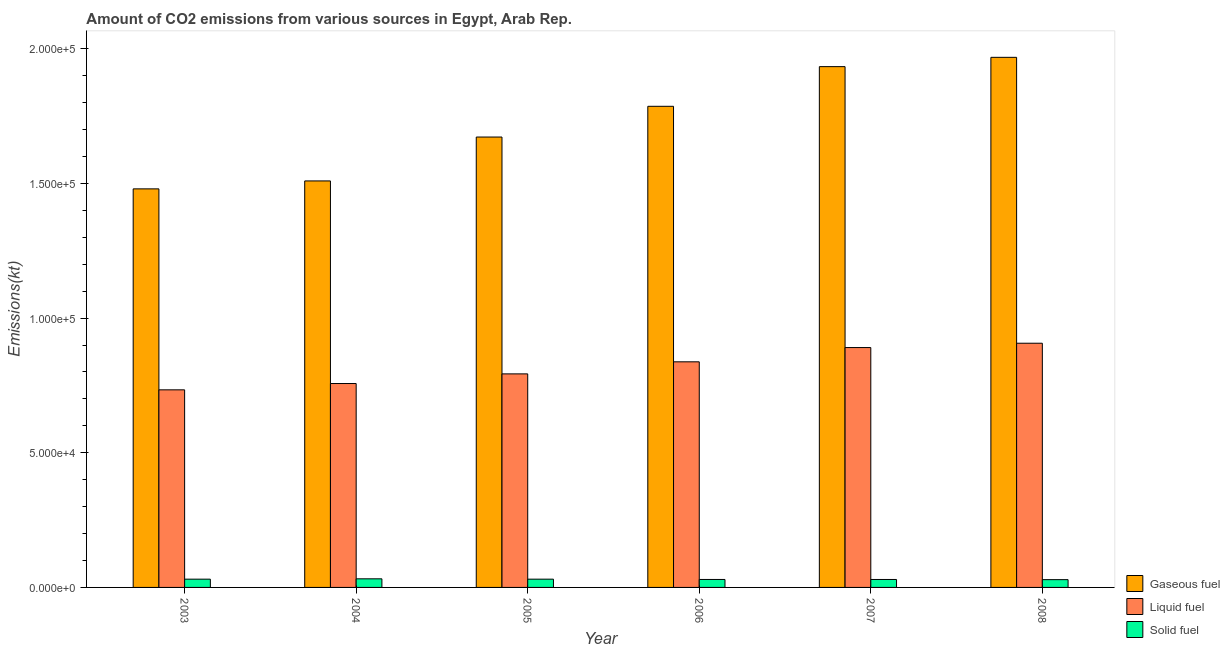How many different coloured bars are there?
Your response must be concise. 3. How many groups of bars are there?
Keep it short and to the point. 6. How many bars are there on the 2nd tick from the left?
Your answer should be compact. 3. How many bars are there on the 5th tick from the right?
Give a very brief answer. 3. What is the amount of co2 emissions from gaseous fuel in 2005?
Keep it short and to the point. 1.67e+05. Across all years, what is the maximum amount of co2 emissions from gaseous fuel?
Ensure brevity in your answer.  1.97e+05. Across all years, what is the minimum amount of co2 emissions from gaseous fuel?
Give a very brief answer. 1.48e+05. In which year was the amount of co2 emissions from solid fuel maximum?
Keep it short and to the point. 2004. In which year was the amount of co2 emissions from gaseous fuel minimum?
Offer a very short reply. 2003. What is the total amount of co2 emissions from liquid fuel in the graph?
Provide a succinct answer. 4.92e+05. What is the difference between the amount of co2 emissions from gaseous fuel in 2003 and that in 2004?
Keep it short and to the point. -2948.27. What is the difference between the amount of co2 emissions from liquid fuel in 2007 and the amount of co2 emissions from solid fuel in 2006?
Your answer should be very brief. 5291.48. What is the average amount of co2 emissions from solid fuel per year?
Offer a terse response. 3021. In the year 2006, what is the difference between the amount of co2 emissions from gaseous fuel and amount of co2 emissions from liquid fuel?
Your answer should be compact. 0. What is the ratio of the amount of co2 emissions from gaseous fuel in 2003 to that in 2004?
Your response must be concise. 0.98. Is the amount of co2 emissions from solid fuel in 2004 less than that in 2008?
Your answer should be very brief. No. What is the difference between the highest and the second highest amount of co2 emissions from gaseous fuel?
Your answer should be compact. 3454.31. What is the difference between the highest and the lowest amount of co2 emissions from liquid fuel?
Offer a very short reply. 1.73e+04. In how many years, is the amount of co2 emissions from liquid fuel greater than the average amount of co2 emissions from liquid fuel taken over all years?
Keep it short and to the point. 3. What does the 3rd bar from the left in 2006 represents?
Your response must be concise. Solid fuel. What does the 2nd bar from the right in 2005 represents?
Offer a terse response. Liquid fuel. Is it the case that in every year, the sum of the amount of co2 emissions from gaseous fuel and amount of co2 emissions from liquid fuel is greater than the amount of co2 emissions from solid fuel?
Your response must be concise. Yes. How many years are there in the graph?
Your answer should be compact. 6. Are the values on the major ticks of Y-axis written in scientific E-notation?
Your answer should be very brief. Yes. How many legend labels are there?
Provide a short and direct response. 3. What is the title of the graph?
Provide a succinct answer. Amount of CO2 emissions from various sources in Egypt, Arab Rep. What is the label or title of the X-axis?
Your answer should be very brief. Year. What is the label or title of the Y-axis?
Ensure brevity in your answer.  Emissions(kt). What is the Emissions(kt) of Gaseous fuel in 2003?
Give a very brief answer. 1.48e+05. What is the Emissions(kt) of Liquid fuel in 2003?
Offer a very short reply. 7.34e+04. What is the Emissions(kt) in Solid fuel in 2003?
Your answer should be very brief. 3065.61. What is the Emissions(kt) of Gaseous fuel in 2004?
Give a very brief answer. 1.51e+05. What is the Emissions(kt) in Liquid fuel in 2004?
Ensure brevity in your answer.  7.57e+04. What is the Emissions(kt) of Solid fuel in 2004?
Offer a very short reply. 3193.96. What is the Emissions(kt) in Gaseous fuel in 2005?
Offer a very short reply. 1.67e+05. What is the Emissions(kt) in Liquid fuel in 2005?
Offer a very short reply. 7.93e+04. What is the Emissions(kt) of Solid fuel in 2005?
Make the answer very short. 3069.28. What is the Emissions(kt) of Gaseous fuel in 2006?
Your response must be concise. 1.79e+05. What is the Emissions(kt) of Liquid fuel in 2006?
Make the answer very short. 8.38e+04. What is the Emissions(kt) in Solid fuel in 2006?
Your answer should be compact. 2959.27. What is the Emissions(kt) of Gaseous fuel in 2007?
Your answer should be compact. 1.93e+05. What is the Emissions(kt) of Liquid fuel in 2007?
Make the answer very short. 8.90e+04. What is the Emissions(kt) in Solid fuel in 2007?
Your answer should be compact. 2951.93. What is the Emissions(kt) in Gaseous fuel in 2008?
Provide a short and direct response. 1.97e+05. What is the Emissions(kt) in Liquid fuel in 2008?
Your answer should be compact. 9.07e+04. What is the Emissions(kt) of Solid fuel in 2008?
Ensure brevity in your answer.  2885.93. Across all years, what is the maximum Emissions(kt) of Gaseous fuel?
Offer a very short reply. 1.97e+05. Across all years, what is the maximum Emissions(kt) of Liquid fuel?
Provide a short and direct response. 9.07e+04. Across all years, what is the maximum Emissions(kt) in Solid fuel?
Provide a succinct answer. 3193.96. Across all years, what is the minimum Emissions(kt) in Gaseous fuel?
Offer a very short reply. 1.48e+05. Across all years, what is the minimum Emissions(kt) of Liquid fuel?
Your response must be concise. 7.34e+04. Across all years, what is the minimum Emissions(kt) of Solid fuel?
Ensure brevity in your answer.  2885.93. What is the total Emissions(kt) in Gaseous fuel in the graph?
Make the answer very short. 1.03e+06. What is the total Emissions(kt) in Liquid fuel in the graph?
Offer a very short reply. 4.92e+05. What is the total Emissions(kt) of Solid fuel in the graph?
Your response must be concise. 1.81e+04. What is the difference between the Emissions(kt) of Gaseous fuel in 2003 and that in 2004?
Offer a very short reply. -2948.27. What is the difference between the Emissions(kt) in Liquid fuel in 2003 and that in 2004?
Provide a short and direct response. -2343.21. What is the difference between the Emissions(kt) in Solid fuel in 2003 and that in 2004?
Provide a short and direct response. -128.34. What is the difference between the Emissions(kt) of Gaseous fuel in 2003 and that in 2005?
Your response must be concise. -1.92e+04. What is the difference between the Emissions(kt) in Liquid fuel in 2003 and that in 2005?
Ensure brevity in your answer.  -5922.2. What is the difference between the Emissions(kt) in Solid fuel in 2003 and that in 2005?
Offer a terse response. -3.67. What is the difference between the Emissions(kt) of Gaseous fuel in 2003 and that in 2006?
Provide a succinct answer. -3.07e+04. What is the difference between the Emissions(kt) in Liquid fuel in 2003 and that in 2006?
Your answer should be very brief. -1.04e+04. What is the difference between the Emissions(kt) of Solid fuel in 2003 and that in 2006?
Your answer should be compact. 106.34. What is the difference between the Emissions(kt) of Gaseous fuel in 2003 and that in 2007?
Offer a very short reply. -4.54e+04. What is the difference between the Emissions(kt) in Liquid fuel in 2003 and that in 2007?
Your answer should be compact. -1.57e+04. What is the difference between the Emissions(kt) in Solid fuel in 2003 and that in 2007?
Provide a short and direct response. 113.68. What is the difference between the Emissions(kt) in Gaseous fuel in 2003 and that in 2008?
Your answer should be very brief. -4.88e+04. What is the difference between the Emissions(kt) of Liquid fuel in 2003 and that in 2008?
Make the answer very short. -1.73e+04. What is the difference between the Emissions(kt) of Solid fuel in 2003 and that in 2008?
Offer a very short reply. 179.68. What is the difference between the Emissions(kt) in Gaseous fuel in 2004 and that in 2005?
Provide a succinct answer. -1.63e+04. What is the difference between the Emissions(kt) of Liquid fuel in 2004 and that in 2005?
Your answer should be very brief. -3578.99. What is the difference between the Emissions(kt) in Solid fuel in 2004 and that in 2005?
Your answer should be compact. 124.68. What is the difference between the Emissions(kt) in Gaseous fuel in 2004 and that in 2006?
Ensure brevity in your answer.  -2.77e+04. What is the difference between the Emissions(kt) of Liquid fuel in 2004 and that in 2006?
Your response must be concise. -8060.07. What is the difference between the Emissions(kt) of Solid fuel in 2004 and that in 2006?
Offer a very short reply. 234.69. What is the difference between the Emissions(kt) in Gaseous fuel in 2004 and that in 2007?
Ensure brevity in your answer.  -4.24e+04. What is the difference between the Emissions(kt) in Liquid fuel in 2004 and that in 2007?
Offer a terse response. -1.34e+04. What is the difference between the Emissions(kt) in Solid fuel in 2004 and that in 2007?
Your answer should be very brief. 242.02. What is the difference between the Emissions(kt) in Gaseous fuel in 2004 and that in 2008?
Make the answer very short. -4.59e+04. What is the difference between the Emissions(kt) of Liquid fuel in 2004 and that in 2008?
Give a very brief answer. -1.50e+04. What is the difference between the Emissions(kt) in Solid fuel in 2004 and that in 2008?
Offer a terse response. 308.03. What is the difference between the Emissions(kt) in Gaseous fuel in 2005 and that in 2006?
Provide a succinct answer. -1.14e+04. What is the difference between the Emissions(kt) in Liquid fuel in 2005 and that in 2006?
Your answer should be very brief. -4481.07. What is the difference between the Emissions(kt) in Solid fuel in 2005 and that in 2006?
Provide a succinct answer. 110.01. What is the difference between the Emissions(kt) of Gaseous fuel in 2005 and that in 2007?
Keep it short and to the point. -2.61e+04. What is the difference between the Emissions(kt) in Liquid fuel in 2005 and that in 2007?
Offer a terse response. -9772.56. What is the difference between the Emissions(kt) in Solid fuel in 2005 and that in 2007?
Ensure brevity in your answer.  117.34. What is the difference between the Emissions(kt) of Gaseous fuel in 2005 and that in 2008?
Make the answer very short. -2.96e+04. What is the difference between the Emissions(kt) in Liquid fuel in 2005 and that in 2008?
Keep it short and to the point. -1.14e+04. What is the difference between the Emissions(kt) of Solid fuel in 2005 and that in 2008?
Make the answer very short. 183.35. What is the difference between the Emissions(kt) in Gaseous fuel in 2006 and that in 2007?
Provide a succinct answer. -1.47e+04. What is the difference between the Emissions(kt) of Liquid fuel in 2006 and that in 2007?
Offer a terse response. -5291.48. What is the difference between the Emissions(kt) in Solid fuel in 2006 and that in 2007?
Your answer should be compact. 7.33. What is the difference between the Emissions(kt) in Gaseous fuel in 2006 and that in 2008?
Your answer should be very brief. -1.82e+04. What is the difference between the Emissions(kt) of Liquid fuel in 2006 and that in 2008?
Your answer should be very brief. -6901.29. What is the difference between the Emissions(kt) of Solid fuel in 2006 and that in 2008?
Your response must be concise. 73.34. What is the difference between the Emissions(kt) in Gaseous fuel in 2007 and that in 2008?
Your response must be concise. -3454.31. What is the difference between the Emissions(kt) in Liquid fuel in 2007 and that in 2008?
Provide a succinct answer. -1609.81. What is the difference between the Emissions(kt) of Solid fuel in 2007 and that in 2008?
Make the answer very short. 66.01. What is the difference between the Emissions(kt) in Gaseous fuel in 2003 and the Emissions(kt) in Liquid fuel in 2004?
Provide a succinct answer. 7.23e+04. What is the difference between the Emissions(kt) of Gaseous fuel in 2003 and the Emissions(kt) of Solid fuel in 2004?
Your answer should be very brief. 1.45e+05. What is the difference between the Emissions(kt) in Liquid fuel in 2003 and the Emissions(kt) in Solid fuel in 2004?
Keep it short and to the point. 7.02e+04. What is the difference between the Emissions(kt) of Gaseous fuel in 2003 and the Emissions(kt) of Liquid fuel in 2005?
Your answer should be compact. 6.87e+04. What is the difference between the Emissions(kt) of Gaseous fuel in 2003 and the Emissions(kt) of Solid fuel in 2005?
Your answer should be compact. 1.45e+05. What is the difference between the Emissions(kt) of Liquid fuel in 2003 and the Emissions(kt) of Solid fuel in 2005?
Make the answer very short. 7.03e+04. What is the difference between the Emissions(kt) of Gaseous fuel in 2003 and the Emissions(kt) of Liquid fuel in 2006?
Make the answer very short. 6.42e+04. What is the difference between the Emissions(kt) of Gaseous fuel in 2003 and the Emissions(kt) of Solid fuel in 2006?
Your response must be concise. 1.45e+05. What is the difference between the Emissions(kt) of Liquid fuel in 2003 and the Emissions(kt) of Solid fuel in 2006?
Ensure brevity in your answer.  7.04e+04. What is the difference between the Emissions(kt) of Gaseous fuel in 2003 and the Emissions(kt) of Liquid fuel in 2007?
Your answer should be very brief. 5.89e+04. What is the difference between the Emissions(kt) of Gaseous fuel in 2003 and the Emissions(kt) of Solid fuel in 2007?
Provide a succinct answer. 1.45e+05. What is the difference between the Emissions(kt) of Liquid fuel in 2003 and the Emissions(kt) of Solid fuel in 2007?
Provide a short and direct response. 7.04e+04. What is the difference between the Emissions(kt) of Gaseous fuel in 2003 and the Emissions(kt) of Liquid fuel in 2008?
Provide a succinct answer. 5.73e+04. What is the difference between the Emissions(kt) of Gaseous fuel in 2003 and the Emissions(kt) of Solid fuel in 2008?
Ensure brevity in your answer.  1.45e+05. What is the difference between the Emissions(kt) in Liquid fuel in 2003 and the Emissions(kt) in Solid fuel in 2008?
Provide a succinct answer. 7.05e+04. What is the difference between the Emissions(kt) of Gaseous fuel in 2004 and the Emissions(kt) of Liquid fuel in 2005?
Offer a terse response. 7.16e+04. What is the difference between the Emissions(kt) in Gaseous fuel in 2004 and the Emissions(kt) in Solid fuel in 2005?
Offer a terse response. 1.48e+05. What is the difference between the Emissions(kt) of Liquid fuel in 2004 and the Emissions(kt) of Solid fuel in 2005?
Offer a very short reply. 7.26e+04. What is the difference between the Emissions(kt) in Gaseous fuel in 2004 and the Emissions(kt) in Liquid fuel in 2006?
Offer a terse response. 6.72e+04. What is the difference between the Emissions(kt) in Gaseous fuel in 2004 and the Emissions(kt) in Solid fuel in 2006?
Offer a terse response. 1.48e+05. What is the difference between the Emissions(kt) in Liquid fuel in 2004 and the Emissions(kt) in Solid fuel in 2006?
Offer a very short reply. 7.27e+04. What is the difference between the Emissions(kt) of Gaseous fuel in 2004 and the Emissions(kt) of Liquid fuel in 2007?
Offer a very short reply. 6.19e+04. What is the difference between the Emissions(kt) of Gaseous fuel in 2004 and the Emissions(kt) of Solid fuel in 2007?
Your answer should be very brief. 1.48e+05. What is the difference between the Emissions(kt) in Liquid fuel in 2004 and the Emissions(kt) in Solid fuel in 2007?
Ensure brevity in your answer.  7.27e+04. What is the difference between the Emissions(kt) of Gaseous fuel in 2004 and the Emissions(kt) of Liquid fuel in 2008?
Your answer should be compact. 6.03e+04. What is the difference between the Emissions(kt) in Gaseous fuel in 2004 and the Emissions(kt) in Solid fuel in 2008?
Offer a terse response. 1.48e+05. What is the difference between the Emissions(kt) of Liquid fuel in 2004 and the Emissions(kt) of Solid fuel in 2008?
Give a very brief answer. 7.28e+04. What is the difference between the Emissions(kt) of Gaseous fuel in 2005 and the Emissions(kt) of Liquid fuel in 2006?
Your answer should be compact. 8.34e+04. What is the difference between the Emissions(kt) of Gaseous fuel in 2005 and the Emissions(kt) of Solid fuel in 2006?
Your response must be concise. 1.64e+05. What is the difference between the Emissions(kt) of Liquid fuel in 2005 and the Emissions(kt) of Solid fuel in 2006?
Provide a short and direct response. 7.63e+04. What is the difference between the Emissions(kt) in Gaseous fuel in 2005 and the Emissions(kt) in Liquid fuel in 2007?
Offer a terse response. 7.82e+04. What is the difference between the Emissions(kt) of Gaseous fuel in 2005 and the Emissions(kt) of Solid fuel in 2007?
Keep it short and to the point. 1.64e+05. What is the difference between the Emissions(kt) in Liquid fuel in 2005 and the Emissions(kt) in Solid fuel in 2007?
Give a very brief answer. 7.63e+04. What is the difference between the Emissions(kt) in Gaseous fuel in 2005 and the Emissions(kt) in Liquid fuel in 2008?
Offer a very short reply. 7.65e+04. What is the difference between the Emissions(kt) in Gaseous fuel in 2005 and the Emissions(kt) in Solid fuel in 2008?
Keep it short and to the point. 1.64e+05. What is the difference between the Emissions(kt) of Liquid fuel in 2005 and the Emissions(kt) of Solid fuel in 2008?
Ensure brevity in your answer.  7.64e+04. What is the difference between the Emissions(kt) in Gaseous fuel in 2006 and the Emissions(kt) in Liquid fuel in 2007?
Keep it short and to the point. 8.96e+04. What is the difference between the Emissions(kt) in Gaseous fuel in 2006 and the Emissions(kt) in Solid fuel in 2007?
Your answer should be compact. 1.76e+05. What is the difference between the Emissions(kt) of Liquid fuel in 2006 and the Emissions(kt) of Solid fuel in 2007?
Offer a very short reply. 8.08e+04. What is the difference between the Emissions(kt) of Gaseous fuel in 2006 and the Emissions(kt) of Liquid fuel in 2008?
Make the answer very short. 8.80e+04. What is the difference between the Emissions(kt) of Gaseous fuel in 2006 and the Emissions(kt) of Solid fuel in 2008?
Offer a terse response. 1.76e+05. What is the difference between the Emissions(kt) of Liquid fuel in 2006 and the Emissions(kt) of Solid fuel in 2008?
Your answer should be compact. 8.09e+04. What is the difference between the Emissions(kt) in Gaseous fuel in 2007 and the Emissions(kt) in Liquid fuel in 2008?
Your answer should be compact. 1.03e+05. What is the difference between the Emissions(kt) of Gaseous fuel in 2007 and the Emissions(kt) of Solid fuel in 2008?
Your response must be concise. 1.90e+05. What is the difference between the Emissions(kt) of Liquid fuel in 2007 and the Emissions(kt) of Solid fuel in 2008?
Ensure brevity in your answer.  8.62e+04. What is the average Emissions(kt) of Gaseous fuel per year?
Ensure brevity in your answer.  1.72e+05. What is the average Emissions(kt) in Liquid fuel per year?
Your answer should be very brief. 8.20e+04. What is the average Emissions(kt) of Solid fuel per year?
Provide a succinct answer. 3021. In the year 2003, what is the difference between the Emissions(kt) in Gaseous fuel and Emissions(kt) in Liquid fuel?
Your answer should be compact. 7.46e+04. In the year 2003, what is the difference between the Emissions(kt) of Gaseous fuel and Emissions(kt) of Solid fuel?
Make the answer very short. 1.45e+05. In the year 2003, what is the difference between the Emissions(kt) in Liquid fuel and Emissions(kt) in Solid fuel?
Give a very brief answer. 7.03e+04. In the year 2004, what is the difference between the Emissions(kt) of Gaseous fuel and Emissions(kt) of Liquid fuel?
Your answer should be compact. 7.52e+04. In the year 2004, what is the difference between the Emissions(kt) of Gaseous fuel and Emissions(kt) of Solid fuel?
Offer a terse response. 1.48e+05. In the year 2004, what is the difference between the Emissions(kt) in Liquid fuel and Emissions(kt) in Solid fuel?
Ensure brevity in your answer.  7.25e+04. In the year 2005, what is the difference between the Emissions(kt) in Gaseous fuel and Emissions(kt) in Liquid fuel?
Provide a short and direct response. 8.79e+04. In the year 2005, what is the difference between the Emissions(kt) of Gaseous fuel and Emissions(kt) of Solid fuel?
Make the answer very short. 1.64e+05. In the year 2005, what is the difference between the Emissions(kt) of Liquid fuel and Emissions(kt) of Solid fuel?
Keep it short and to the point. 7.62e+04. In the year 2006, what is the difference between the Emissions(kt) in Gaseous fuel and Emissions(kt) in Liquid fuel?
Give a very brief answer. 9.49e+04. In the year 2006, what is the difference between the Emissions(kt) in Gaseous fuel and Emissions(kt) in Solid fuel?
Ensure brevity in your answer.  1.76e+05. In the year 2006, what is the difference between the Emissions(kt) in Liquid fuel and Emissions(kt) in Solid fuel?
Provide a succinct answer. 8.08e+04. In the year 2007, what is the difference between the Emissions(kt) of Gaseous fuel and Emissions(kt) of Liquid fuel?
Your answer should be compact. 1.04e+05. In the year 2007, what is the difference between the Emissions(kt) of Gaseous fuel and Emissions(kt) of Solid fuel?
Your answer should be compact. 1.90e+05. In the year 2007, what is the difference between the Emissions(kt) in Liquid fuel and Emissions(kt) in Solid fuel?
Give a very brief answer. 8.61e+04. In the year 2008, what is the difference between the Emissions(kt) of Gaseous fuel and Emissions(kt) of Liquid fuel?
Your response must be concise. 1.06e+05. In the year 2008, what is the difference between the Emissions(kt) in Gaseous fuel and Emissions(kt) in Solid fuel?
Your answer should be compact. 1.94e+05. In the year 2008, what is the difference between the Emissions(kt) in Liquid fuel and Emissions(kt) in Solid fuel?
Offer a very short reply. 8.78e+04. What is the ratio of the Emissions(kt) of Gaseous fuel in 2003 to that in 2004?
Offer a very short reply. 0.98. What is the ratio of the Emissions(kt) in Liquid fuel in 2003 to that in 2004?
Provide a succinct answer. 0.97. What is the ratio of the Emissions(kt) of Solid fuel in 2003 to that in 2004?
Provide a succinct answer. 0.96. What is the ratio of the Emissions(kt) in Gaseous fuel in 2003 to that in 2005?
Your answer should be compact. 0.88. What is the ratio of the Emissions(kt) in Liquid fuel in 2003 to that in 2005?
Ensure brevity in your answer.  0.93. What is the ratio of the Emissions(kt) of Solid fuel in 2003 to that in 2005?
Make the answer very short. 1. What is the ratio of the Emissions(kt) in Gaseous fuel in 2003 to that in 2006?
Your response must be concise. 0.83. What is the ratio of the Emissions(kt) in Liquid fuel in 2003 to that in 2006?
Ensure brevity in your answer.  0.88. What is the ratio of the Emissions(kt) in Solid fuel in 2003 to that in 2006?
Make the answer very short. 1.04. What is the ratio of the Emissions(kt) of Gaseous fuel in 2003 to that in 2007?
Offer a terse response. 0.77. What is the ratio of the Emissions(kt) in Liquid fuel in 2003 to that in 2007?
Your response must be concise. 0.82. What is the ratio of the Emissions(kt) of Gaseous fuel in 2003 to that in 2008?
Provide a succinct answer. 0.75. What is the ratio of the Emissions(kt) of Liquid fuel in 2003 to that in 2008?
Your response must be concise. 0.81. What is the ratio of the Emissions(kt) of Solid fuel in 2003 to that in 2008?
Your response must be concise. 1.06. What is the ratio of the Emissions(kt) of Gaseous fuel in 2004 to that in 2005?
Give a very brief answer. 0.9. What is the ratio of the Emissions(kt) of Liquid fuel in 2004 to that in 2005?
Provide a succinct answer. 0.95. What is the ratio of the Emissions(kt) of Solid fuel in 2004 to that in 2005?
Keep it short and to the point. 1.04. What is the ratio of the Emissions(kt) in Gaseous fuel in 2004 to that in 2006?
Make the answer very short. 0.84. What is the ratio of the Emissions(kt) of Liquid fuel in 2004 to that in 2006?
Your response must be concise. 0.9. What is the ratio of the Emissions(kt) in Solid fuel in 2004 to that in 2006?
Offer a terse response. 1.08. What is the ratio of the Emissions(kt) of Gaseous fuel in 2004 to that in 2007?
Keep it short and to the point. 0.78. What is the ratio of the Emissions(kt) of Liquid fuel in 2004 to that in 2007?
Provide a succinct answer. 0.85. What is the ratio of the Emissions(kt) of Solid fuel in 2004 to that in 2007?
Provide a succinct answer. 1.08. What is the ratio of the Emissions(kt) of Gaseous fuel in 2004 to that in 2008?
Keep it short and to the point. 0.77. What is the ratio of the Emissions(kt) of Liquid fuel in 2004 to that in 2008?
Keep it short and to the point. 0.83. What is the ratio of the Emissions(kt) in Solid fuel in 2004 to that in 2008?
Keep it short and to the point. 1.11. What is the ratio of the Emissions(kt) of Gaseous fuel in 2005 to that in 2006?
Your answer should be very brief. 0.94. What is the ratio of the Emissions(kt) in Liquid fuel in 2005 to that in 2006?
Offer a very short reply. 0.95. What is the ratio of the Emissions(kt) of Solid fuel in 2005 to that in 2006?
Provide a succinct answer. 1.04. What is the ratio of the Emissions(kt) in Gaseous fuel in 2005 to that in 2007?
Provide a succinct answer. 0.86. What is the ratio of the Emissions(kt) of Liquid fuel in 2005 to that in 2007?
Your answer should be compact. 0.89. What is the ratio of the Emissions(kt) in Solid fuel in 2005 to that in 2007?
Provide a short and direct response. 1.04. What is the ratio of the Emissions(kt) of Gaseous fuel in 2005 to that in 2008?
Ensure brevity in your answer.  0.85. What is the ratio of the Emissions(kt) in Liquid fuel in 2005 to that in 2008?
Your answer should be compact. 0.87. What is the ratio of the Emissions(kt) of Solid fuel in 2005 to that in 2008?
Provide a short and direct response. 1.06. What is the ratio of the Emissions(kt) in Gaseous fuel in 2006 to that in 2007?
Make the answer very short. 0.92. What is the ratio of the Emissions(kt) of Liquid fuel in 2006 to that in 2007?
Your response must be concise. 0.94. What is the ratio of the Emissions(kt) of Solid fuel in 2006 to that in 2007?
Make the answer very short. 1. What is the ratio of the Emissions(kt) in Gaseous fuel in 2006 to that in 2008?
Your answer should be compact. 0.91. What is the ratio of the Emissions(kt) of Liquid fuel in 2006 to that in 2008?
Keep it short and to the point. 0.92. What is the ratio of the Emissions(kt) in Solid fuel in 2006 to that in 2008?
Ensure brevity in your answer.  1.03. What is the ratio of the Emissions(kt) in Gaseous fuel in 2007 to that in 2008?
Provide a succinct answer. 0.98. What is the ratio of the Emissions(kt) in Liquid fuel in 2007 to that in 2008?
Give a very brief answer. 0.98. What is the ratio of the Emissions(kt) in Solid fuel in 2007 to that in 2008?
Make the answer very short. 1.02. What is the difference between the highest and the second highest Emissions(kt) in Gaseous fuel?
Give a very brief answer. 3454.31. What is the difference between the highest and the second highest Emissions(kt) of Liquid fuel?
Make the answer very short. 1609.81. What is the difference between the highest and the second highest Emissions(kt) in Solid fuel?
Offer a terse response. 124.68. What is the difference between the highest and the lowest Emissions(kt) in Gaseous fuel?
Provide a succinct answer. 4.88e+04. What is the difference between the highest and the lowest Emissions(kt) in Liquid fuel?
Provide a succinct answer. 1.73e+04. What is the difference between the highest and the lowest Emissions(kt) of Solid fuel?
Your answer should be very brief. 308.03. 